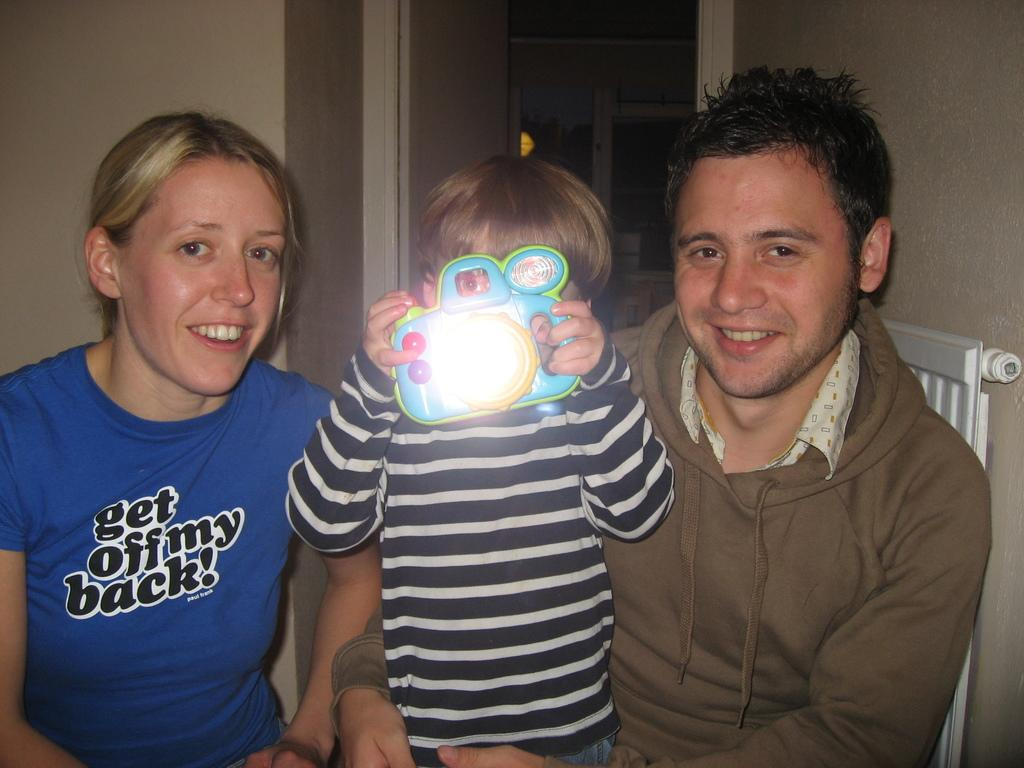How many people are in the image? There are three people in the image: a man, a woman, and a small girl. What is the small girl holding in her hands? The small girl is holding a toy in her hands. Where are the subjects located in the image? The subjects are in the center of the image. What can be seen at the top side of the image? There is a door at the top side of the image. What type of garden can be seen through the door in the image? There is no garden visible through the door in the image; only the door itself is mentioned. Who is the friend of the small girl in the image? There is no mention of a friend in the image; the small girl is accompanied by a man and a woman. 